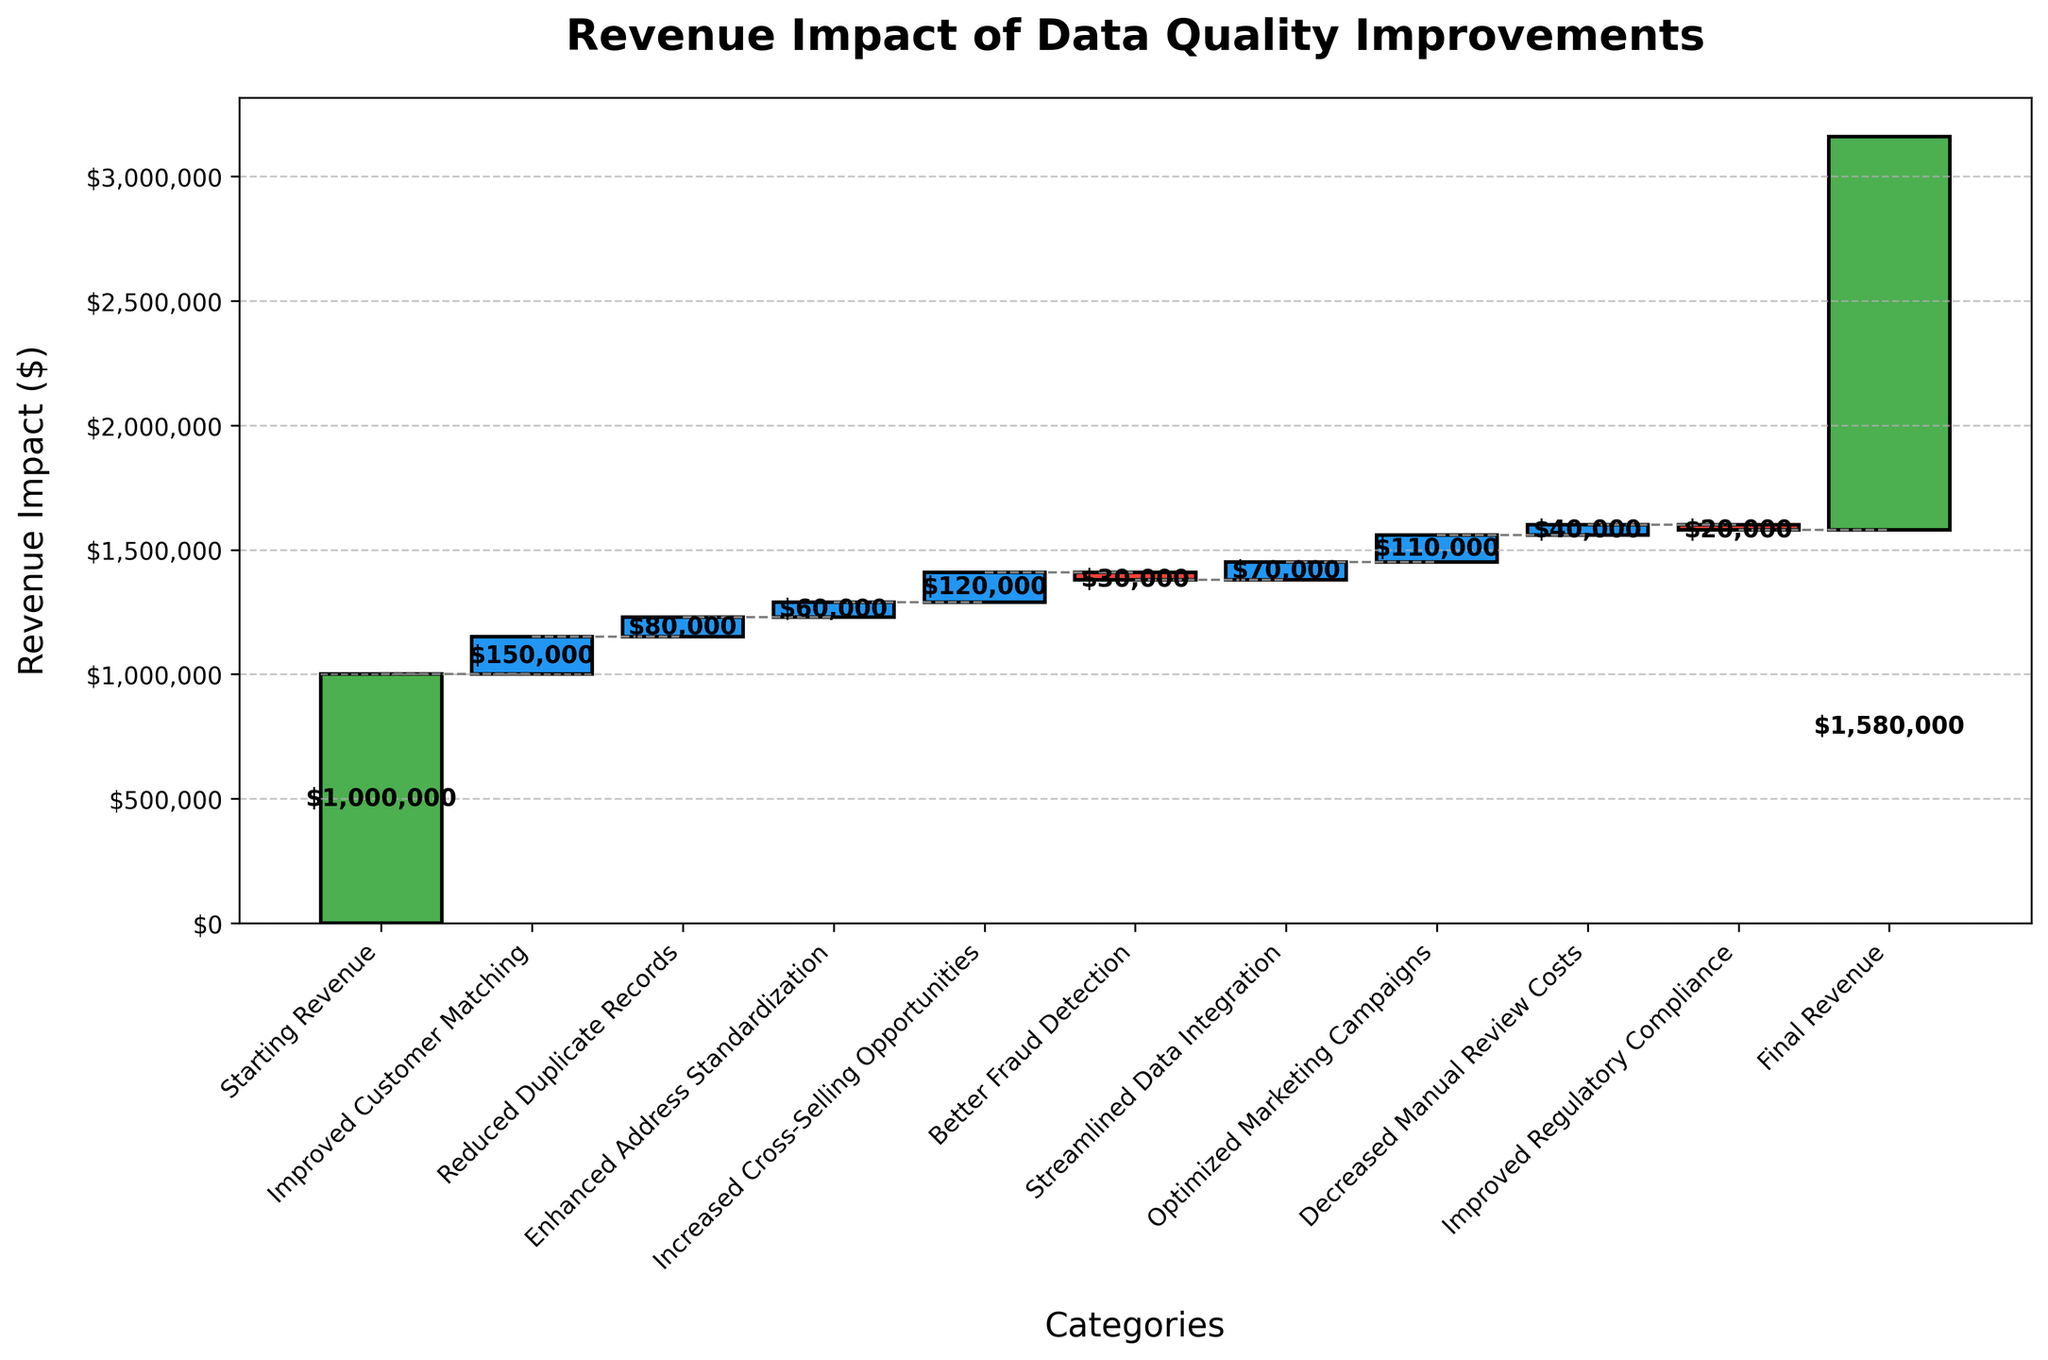What is the title of the chart? The title of a chart is typically located at the top of the figure. In this case, it reads, "Revenue Impact of Data Quality Improvements".
Answer: Revenue Impact of Data Quality Improvements What is the starting revenue in the chart? The starting revenue is mentioned as the first category in the chart. It is represented by the first bar, labeled "Starting Revenue".
Answer: $1,000,000 What is the final revenue after all improvements? The final revenue is depicted by the last bar on the chart. It is marked as "Final Revenue".
Answer: $1,580,000 Which category had the highest positive impact on revenue? To determine the highest positive impact, we need to identify the bar with the maximum height among the positive value categories. "Improved Customer Matching" had a $150,000 impact, which is the highest among the positive impacts.
Answer: Improved Customer Matching What is the cumulative impact of "Enhanced Address Standardization" and "Increased Cross-Selling Opportunities"? First, identify the values associated with "Enhanced Address Standardization" ($60,000) and "Increased Cross-Selling Opportunities" ($120,000). Sum these values to get the cumulative impact.
Answer: $180,000 How much did "Better Fraud Detection" decrease the revenue? Locate the "Better Fraud Detection" bar and identify its value. The value is represented as a negative impact, which is $30,000.
Answer: $30,000 Which category caused the smallest positive impact on revenue? To find the smallest positive impact, compare the values of the bars representing positive impacts. "Enhanced Address Standardization" has the smallest positive impact at $60,000.
Answer: Enhanced Address Standardization What is the total increase in revenue from "Improved Customer Matching" to "Optimized Marketing Campaigns"? Sum the positive impacts of "Improved Customer Matching" ($150,000), "Reduced Duplicate Records" ($80,000), "Enhanced Address Standardization" ($60,000), "Increased Cross-Selling Opportunities" ($120,000), "Streamlined Data Integration" ($70,000), and "Optimized Marketing Campaigns" ($110,000). This totals $590,000.
Answer: $590,000 How many categories have a positive impact on revenue? Count the number of bars that represent positive impacts, excluding the starting and final revenue bars. There are six categories with positive impacts: "Improved Customer Matching", "Reduced Duplicate Records", "Enhanced Address Standardization", "Increased Cross-Selling Opportunities", "Streamlined Data Integration", and "Optimized Marketing Campaigns".
Answer: 6 How much more did "Optimized Marketing Campaigns" impact revenue compared to "Reduced Duplicate Records"? Identify the values of "Optimized Marketing Campaigns" ($110,000) and "Reduced Duplicate Records" ($80,000). Subtract the smaller value from the larger value to get the difference: $110,000 - $80,000 = $30,000.
Answer: $30,000 